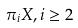Convert formula to latex. <formula><loc_0><loc_0><loc_500><loc_500>\pi _ { i } X , i \geq 2</formula> 